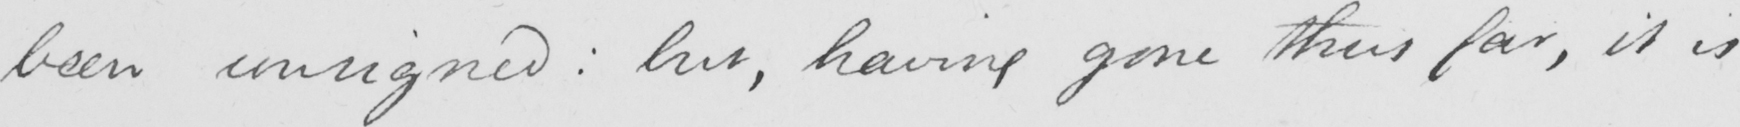Please provide the text content of this handwritten line. been consigned :  but , having gone thus far , it is 